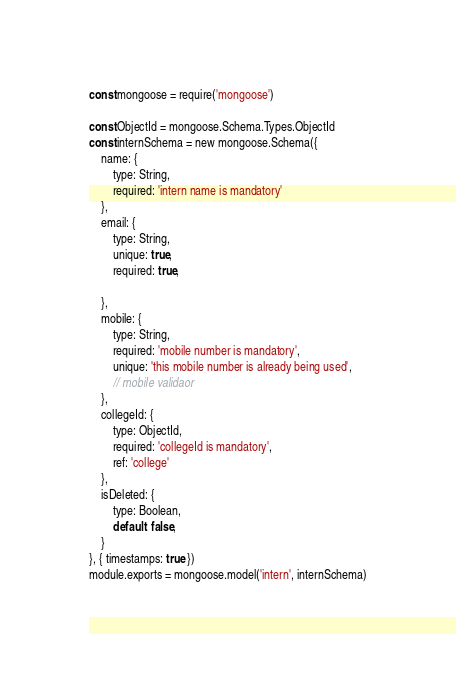<code> <loc_0><loc_0><loc_500><loc_500><_JavaScript_>const mongoose = require('mongoose')

const ObjectId = mongoose.Schema.Types.ObjectId
const internSchema = new mongoose.Schema({
    name: {
        type: String,
        required: 'intern name is mandatory'
    },
    email: {
        type: String,
        unique: true,
        required: true,

    },
    mobile: {
        type: String,
        required: 'mobile number is mandatory',
        unique: 'this mobile number is already being used',
        // mobile validaor
    },
    collegeId: {
        type: ObjectId,
        required: 'collegeId is mandatory',
        ref: 'college'
    },
    isDeleted: {
        type: Boolean,
        default: false,
    }
}, { timestamps: true })
module.exports = mongoose.model('intern', internSchema)
</code> 